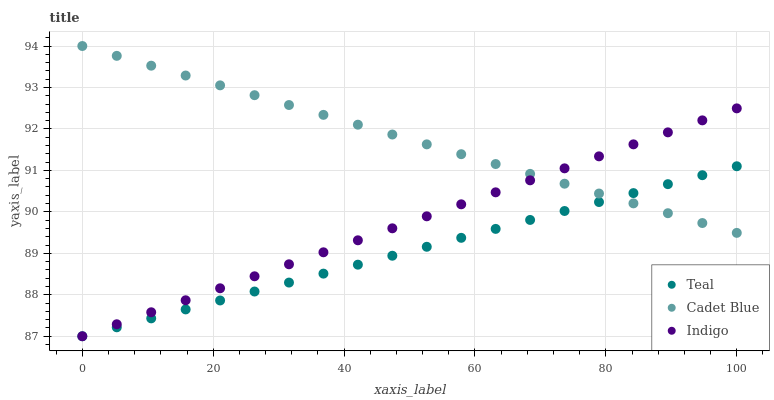Does Teal have the minimum area under the curve?
Answer yes or no. Yes. Does Cadet Blue have the maximum area under the curve?
Answer yes or no. Yes. Does Indigo have the minimum area under the curve?
Answer yes or no. No. Does Indigo have the maximum area under the curve?
Answer yes or no. No. Is Indigo the smoothest?
Answer yes or no. Yes. Is Teal the roughest?
Answer yes or no. Yes. Is Teal the smoothest?
Answer yes or no. No. Is Indigo the roughest?
Answer yes or no. No. Does Indigo have the lowest value?
Answer yes or no. Yes. Does Cadet Blue have the highest value?
Answer yes or no. Yes. Does Indigo have the highest value?
Answer yes or no. No. Does Teal intersect Cadet Blue?
Answer yes or no. Yes. Is Teal less than Cadet Blue?
Answer yes or no. No. Is Teal greater than Cadet Blue?
Answer yes or no. No. 